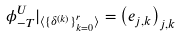Convert formula to latex. <formula><loc_0><loc_0><loc_500><loc_500>\phi _ { - T } ^ { U } | _ { \langle \{ \delta ^ { ( k ) } \} _ { k = 0 } ^ { r } \rangle } = \left ( e _ { j , k } \right ) _ { j , k }</formula> 